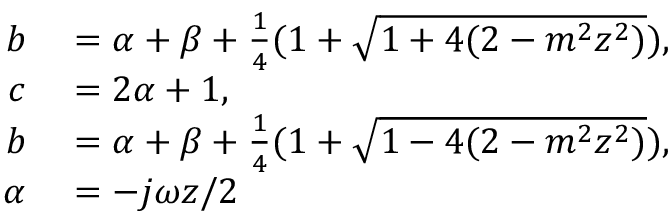<formula> <loc_0><loc_0><loc_500><loc_500>\begin{array} { r l } { b } & = \alpha + \beta + \frac { 1 } { 4 } ( 1 + \sqrt { 1 + 4 ( 2 - m ^ { 2 } z ^ { 2 } ) } ) , } \\ { c } & = 2 \alpha + 1 , } \\ { b } & = \alpha + \beta + \frac { 1 } { 4 } ( 1 + \sqrt { 1 - 4 ( 2 - m ^ { 2 } z ^ { 2 } ) } ) , } \\ { \alpha } & = - j \omega z / 2 } \end{array}</formula> 